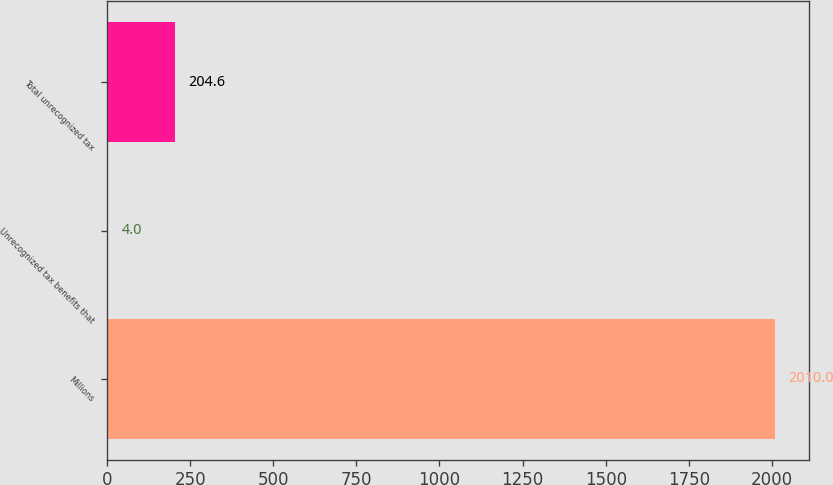Convert chart to OTSL. <chart><loc_0><loc_0><loc_500><loc_500><bar_chart><fcel>Millions<fcel>Unrecognized tax benefits that<fcel>Total unrecognized tax<nl><fcel>2010<fcel>4<fcel>204.6<nl></chart> 